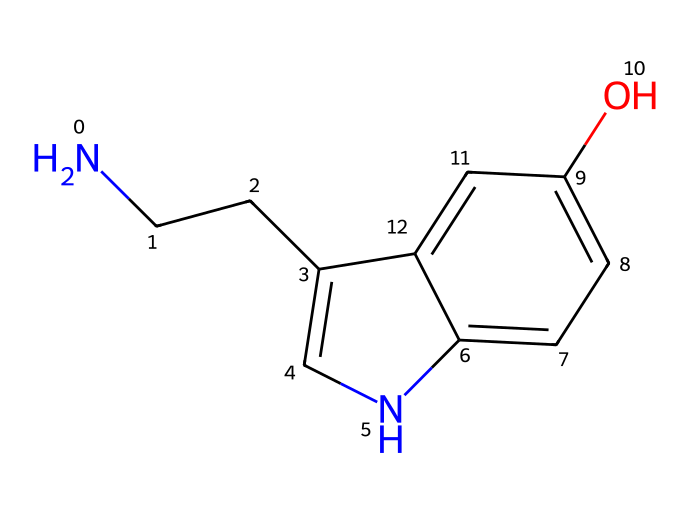What is the total number of carbon atoms in the chemical structure? By analyzing the SMILES representation, we can count the carbon atoms (C). The SMILES notation shows a total of 10 carbon atoms when considering the entire ring and chain structure.
Answer: 10 How many nitrogen atoms are present in the structure? The SMILES notation contains two nitrogen symbols (N), indicating the presence of two nitrogen atoms in the molecule.
Answer: 2 What feature of this chemical structure is indicative of its function as a neurotransmitter? The presence of a hydroxyl group (-OH) attached to the aromatic ring indicates that it can form hydrogen bonds, which is important for its interactions as a neurotransmitter.
Answer: hydroxyl group Which part of the chemical is responsible for mood regulation? The entire molecule, but particularly the amine group (NH) connected to a carbon chain allows it to interact with receptor sites in the brain, thus playing a role in mood regulation.
Answer: amine group What is the molecular formula derived from the given SMILES representation? By analyzing the counts of each type of atom (C, H, N, O) in the SMILES representation, we can conclude that the molecular formula corresponding to this structure is C10H12N2O.
Answer: C10H12N2O Does this molecule contain any double bonds? The SMILES notation does not indicate any double bonds (i.e., no '=' signs are present), confirming that all carbon atoms are connected by single bonds.
Answer: no 